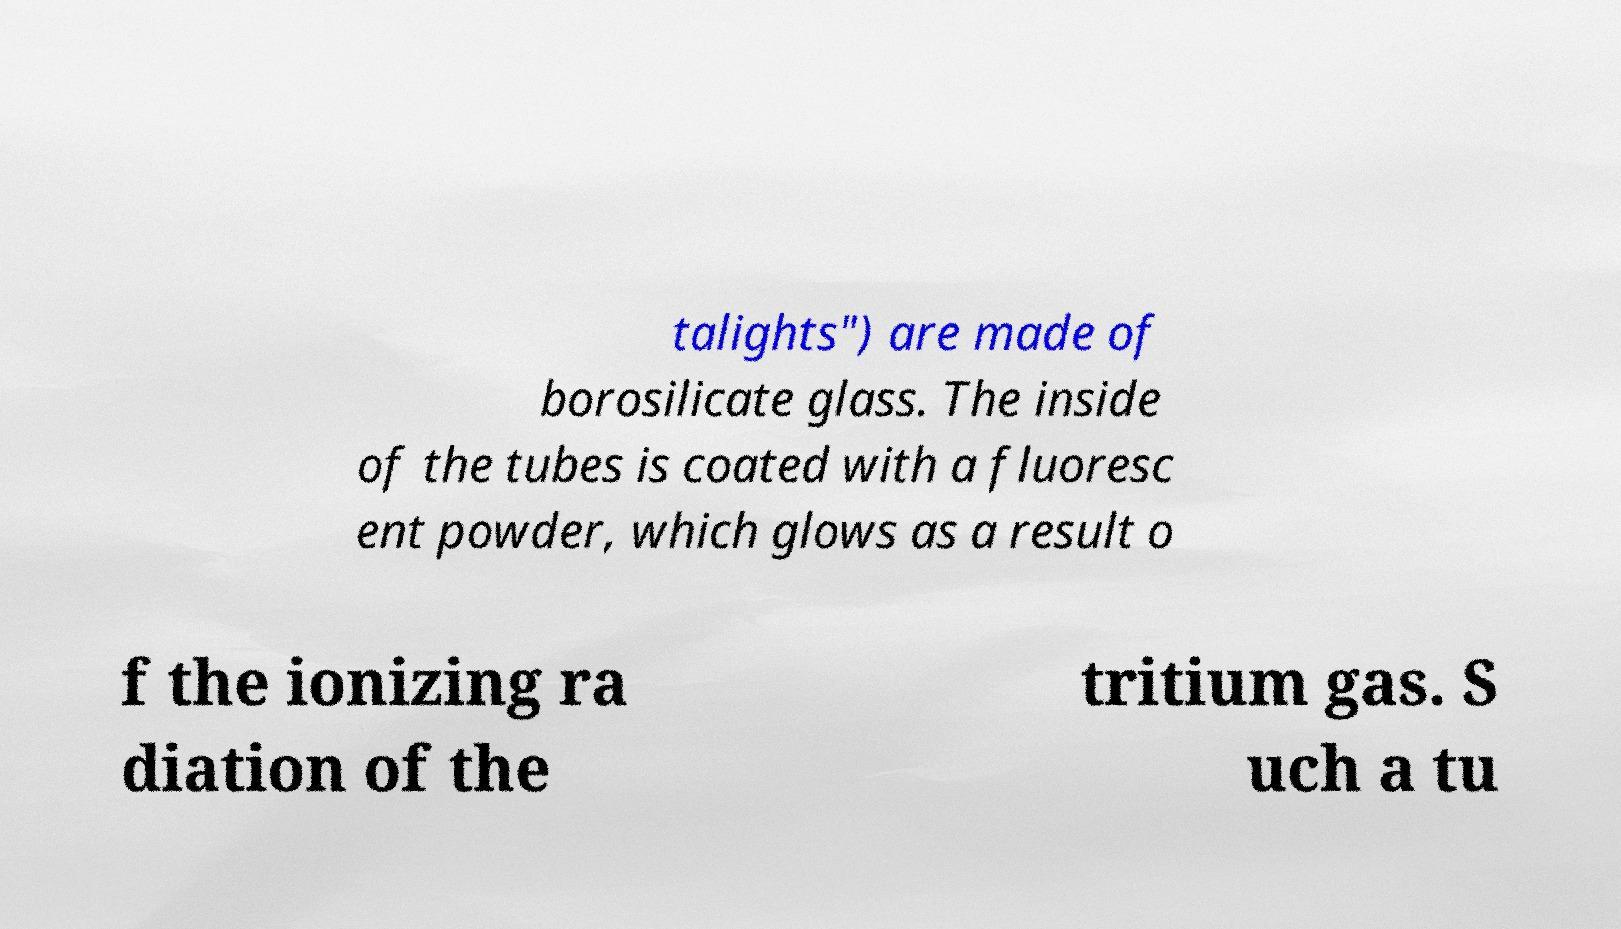For documentation purposes, I need the text within this image transcribed. Could you provide that? talights") are made of borosilicate glass. The inside of the tubes is coated with a fluoresc ent powder, which glows as a result o f the ionizing ra diation of the tritium gas. S uch a tu 